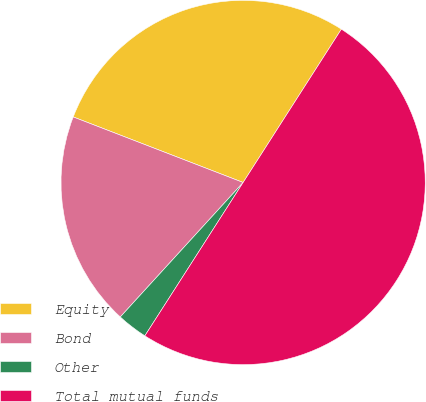Convert chart to OTSL. <chart><loc_0><loc_0><loc_500><loc_500><pie_chart><fcel>Equity<fcel>Bond<fcel>Other<fcel>Total mutual funds<nl><fcel>28.21%<fcel>19.08%<fcel>2.71%<fcel>50.0%<nl></chart> 